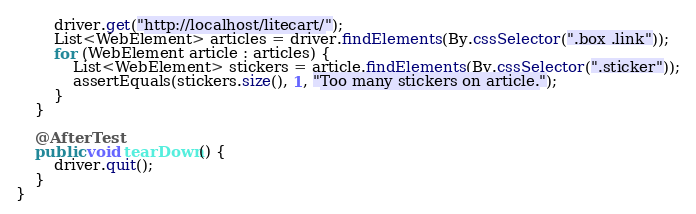<code> <loc_0><loc_0><loc_500><loc_500><_Java_>        driver.get("http://localhost/litecart/");
        List<WebElement> articles = driver.findElements(By.cssSelector(".box .link"));
        for (WebElement article : articles) {
            List<WebElement> stickers = article.findElements(By.cssSelector(".sticker"));
            assertEquals(stickers.size(), 1, "Too many stickers on article.");
        }
    }

    @AfterTest
    public void tearDown() {
        driver.quit();
    }
}
</code> 